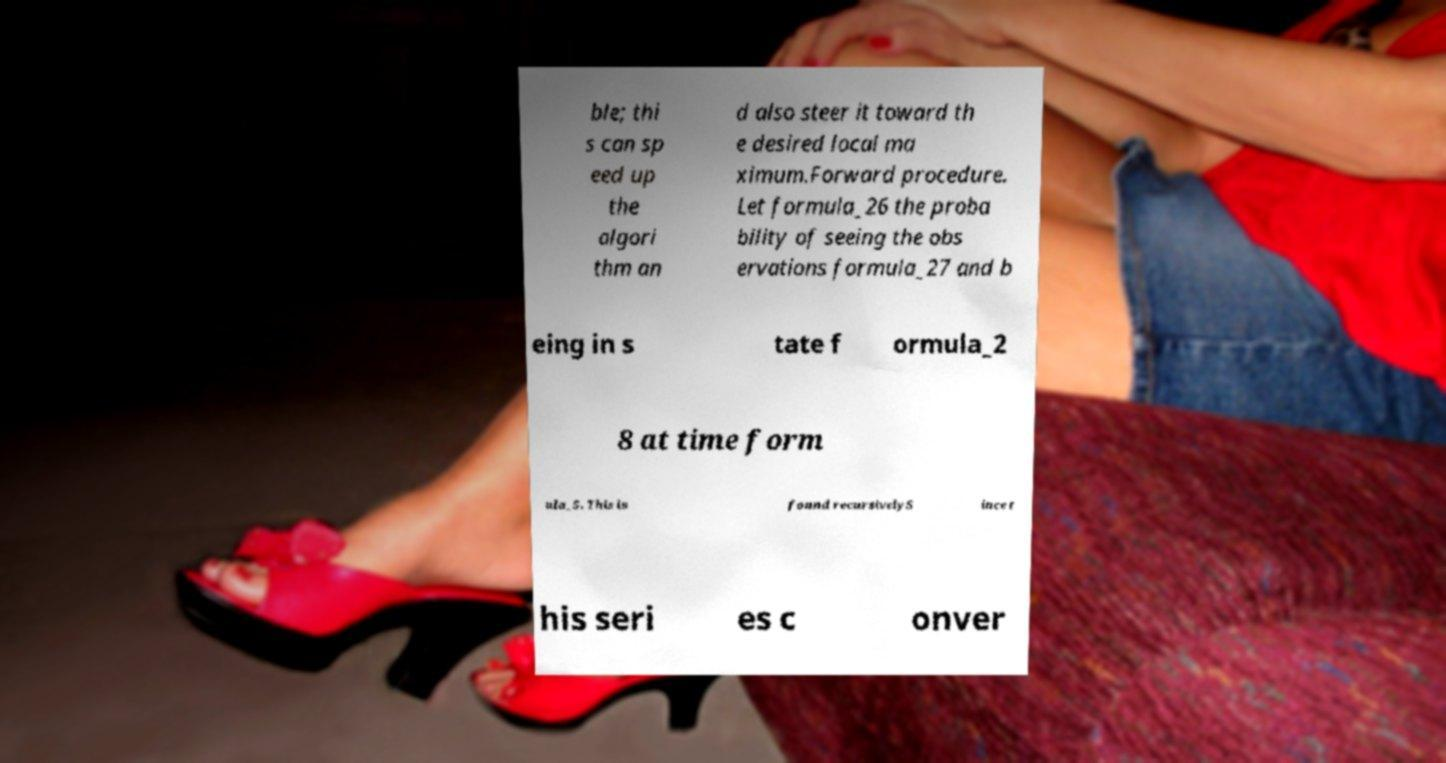I need the written content from this picture converted into text. Can you do that? ble; thi s can sp eed up the algori thm an d also steer it toward th e desired local ma ximum.Forward procedure. Let formula_26 the proba bility of seeing the obs ervations formula_27 and b eing in s tate f ormula_2 8 at time form ula_5. This is found recursivelyS ince t his seri es c onver 